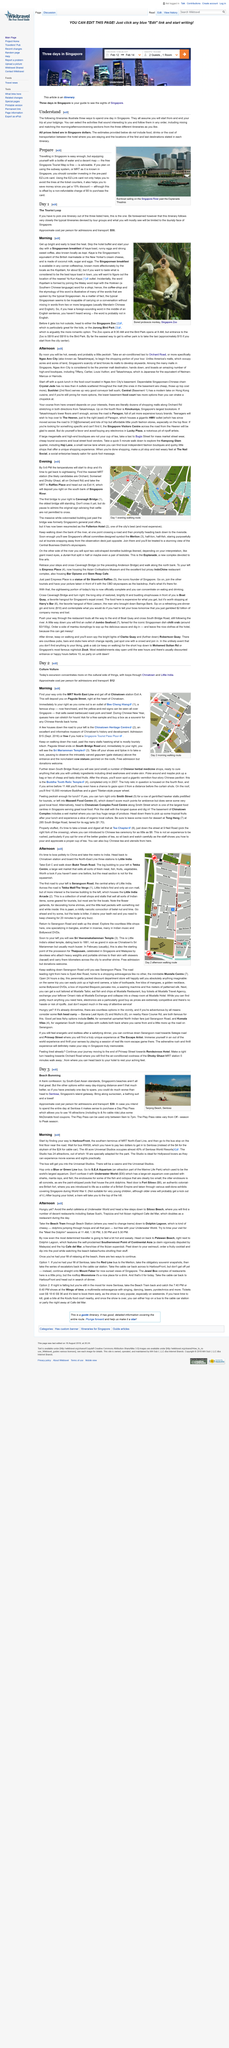Highlight a few significant elements in this photo. It is confirmed that 3 itineraries are provided. The prices are listed in Singapore dollars. It is recommended that one day be allocated to complete the activities outlined in these itineraries. 